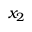<formula> <loc_0><loc_0><loc_500><loc_500>x _ { 2 }</formula> 